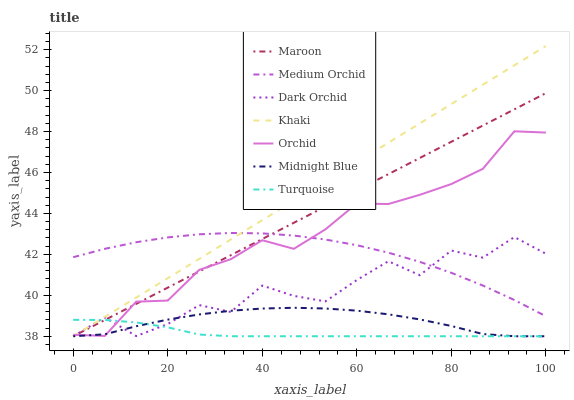Does Turquoise have the minimum area under the curve?
Answer yes or no. Yes. Does Khaki have the maximum area under the curve?
Answer yes or no. Yes. Does Midnight Blue have the minimum area under the curve?
Answer yes or no. No. Does Midnight Blue have the maximum area under the curve?
Answer yes or no. No. Is Maroon the smoothest?
Answer yes or no. Yes. Is Dark Orchid the roughest?
Answer yes or no. Yes. Is Khaki the smoothest?
Answer yes or no. No. Is Khaki the roughest?
Answer yes or no. No. Does Medium Orchid have the lowest value?
Answer yes or no. No. Does Midnight Blue have the highest value?
Answer yes or no. No. Is Midnight Blue less than Medium Orchid?
Answer yes or no. Yes. Is Medium Orchid greater than Turquoise?
Answer yes or no. Yes. Does Midnight Blue intersect Medium Orchid?
Answer yes or no. No. 